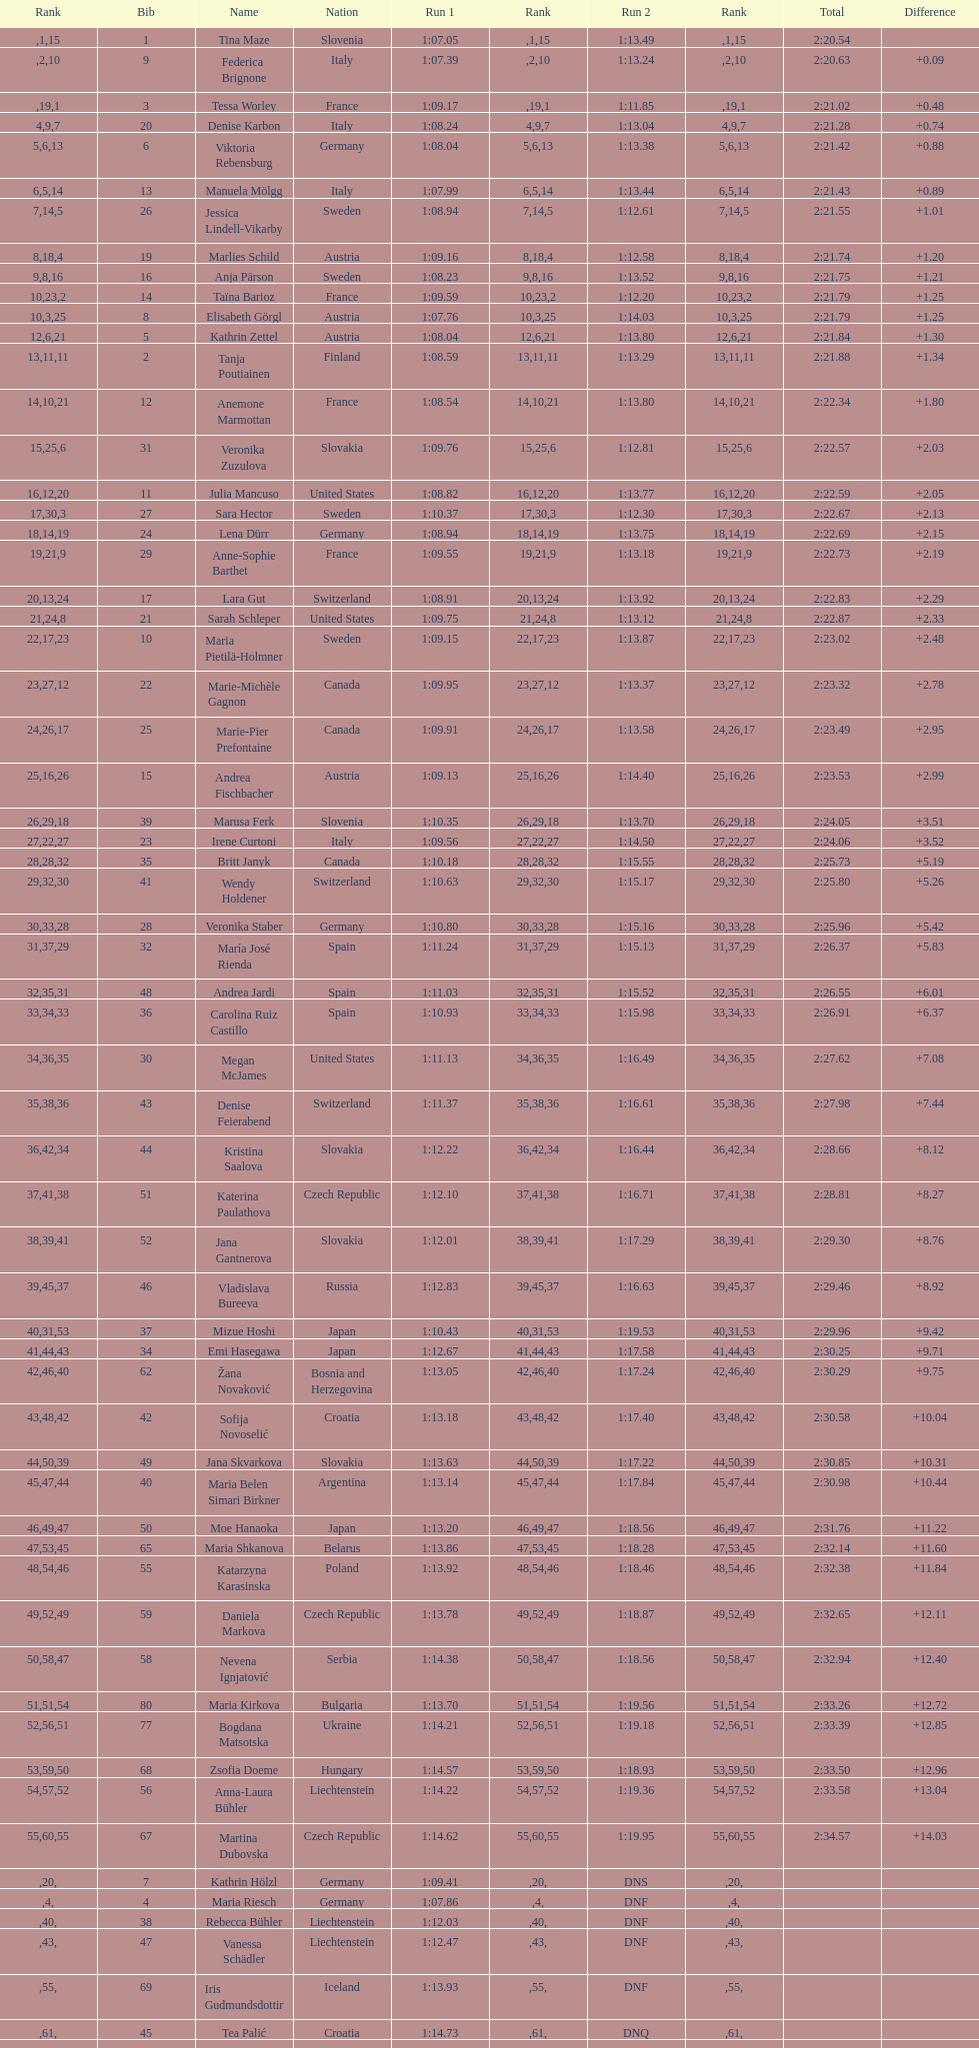Which competitor was the last one to finish both runs? Martina Dubovska. 